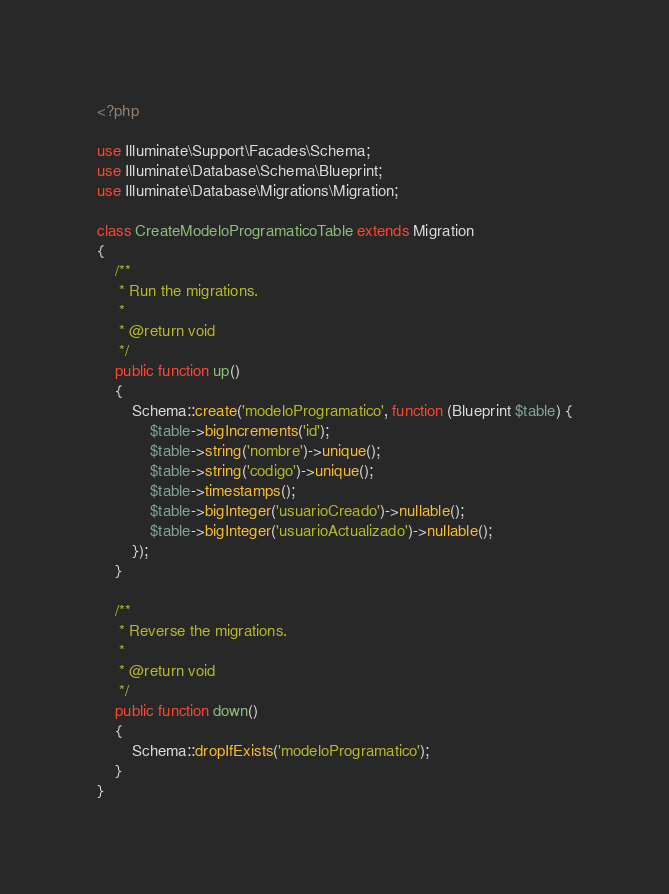Convert code to text. <code><loc_0><loc_0><loc_500><loc_500><_PHP_><?php

use Illuminate\Support\Facades\Schema;
use Illuminate\Database\Schema\Blueprint;
use Illuminate\Database\Migrations\Migration;

class CreateModeloProgramaticoTable extends Migration
{
    /**
     * Run the migrations.
     *
     * @return void
     */
    public function up()
    {
        Schema::create('modeloProgramatico', function (Blueprint $table) {
            $table->bigIncrements('id');
            $table->string('nombre')->unique();
            $table->string('codigo')->unique();
            $table->timestamps();
            $table->bigInteger('usuarioCreado')->nullable();
            $table->bigInteger('usuarioActualizado')->nullable();
        });
    }

    /**
     * Reverse the migrations.
     *
     * @return void
     */
    public function down()
    {
        Schema::dropIfExists('modeloProgramatico');
    }
}
</code> 